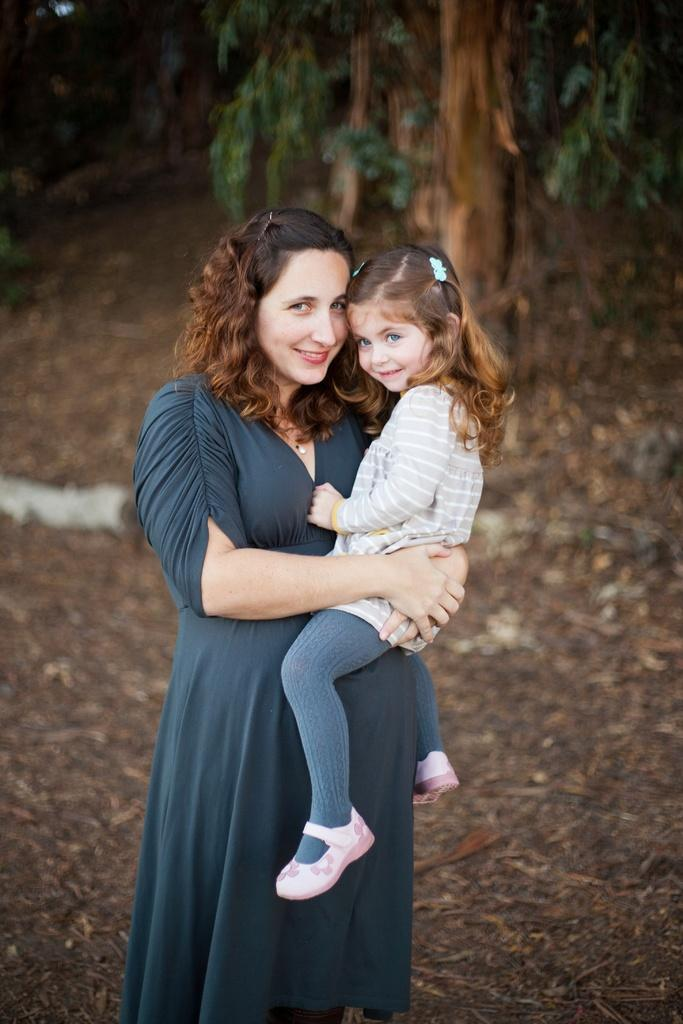What is the main subject of the image? There is a woman in the image. What is the woman wearing? The woman is wearing clothes. What is the woman doing in the image? The woman is holding a girl. What accessories can be seen in the image? There are hair clips in the image. What natural elements are present in the image? There are dry leaves, soil, and a tree in the image. What type of print can be seen on the girl's shirt? There is no mention of a shirt or any print in the provided facts. --- Facts: 1. There is a man in the image. 2. The man is wearing a hat. 3. The man is holding a book. 4. The book has a red cover. 5. There is a wooden bench in the image. 6. The bench is located near a tree. Absurd Topics: unicorn, magic wand, fairy Conversation: Who is the main subject in the image? There is a man in the image. What is the man wearing on his head? The man is wearing a hat. What is the man holding in his hands? The man is holding a book. What is the color of the book's cover? The book has a red cover. What type of furniture can be seen in the image? There is a wooden bench in the image. Where is the wooden bench located in the image? The bench is located near a tree. Reasoning: Let's think step by step in order to produce the conversation. We start by identifying the main subject of the image, which is the man. Then, we describe the man's clothing and accessories, such as the hat. Next, we observe the man's actions, noting that he is holding a book. We then describe the book's cover, which is red. After that, we identify any other objects or furniture present in the image, such as the wooden bench. Finally, we describe the location of the wooden bench in relation to other elements in the image, such as the tree. Absurd Question/Answer: How many unicorns can be seen grazing near the tree in the image? There is no mention of unicorns in the provided facts. --- Facts: 1. There is a cat in the image. 2. The cat is sitting on a windowsill. 3. The windowsill is located near a flowerpot. 4. The flowerpot contains a small plant. 5. The small plant has green leaves. Absurd Topics: spaceship, alien creature, cosmic dust Conversation: What type of animal can be seen in the image? There is a cat in the image. Where is the cat located in the image? The cat is sitting on a windows 